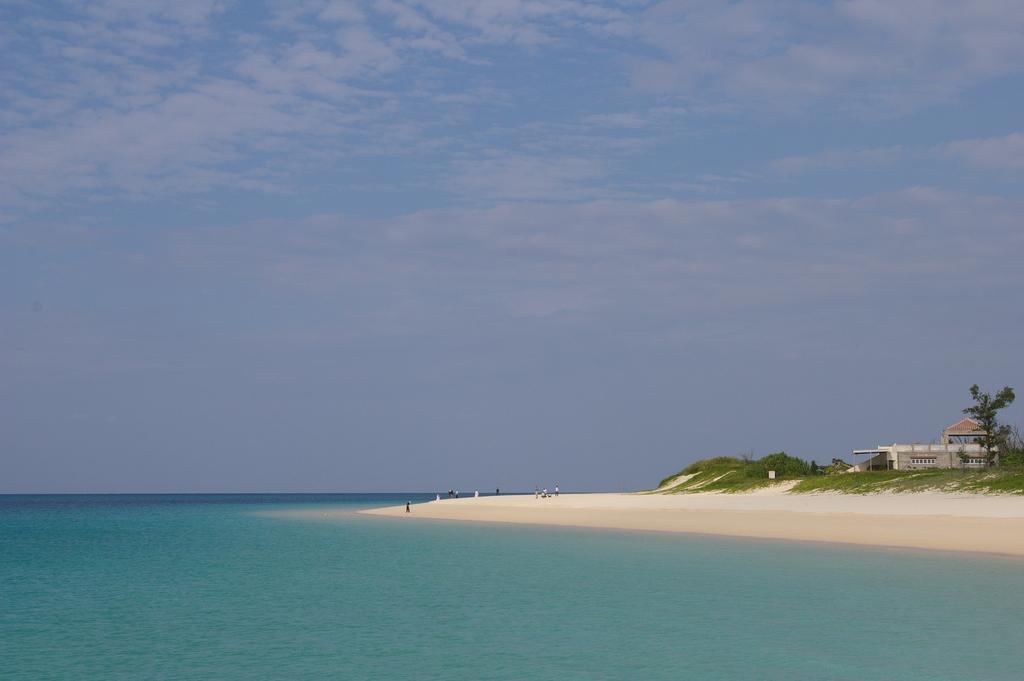In one or two sentences, can you explain what this image depicts? In this image we can see water, on right side of the image there is sand and some persons standing at the seashore, there is some grass, house and trees and top of the image there is clear sky. 